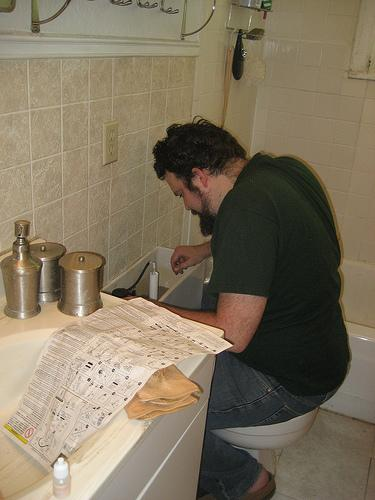What is the man in the image doing and how is he dressed? The man is fixing a toilet while wearing a black shirt, blue jeans, and tan work gloves. If you were to ask a complex question about this image, what would it be, and what would the answer entail? Answer: The man's attire, including a casual black shirt and blue jeans along with tan work gloves, suggests that he may not be a professional plumber. The presence of an instruction paper indicates that he might be attempting a DIY repair job. List three objects in the image that are related to electrical outlets or connections. Standard white electric outlet, electrical outlet in the wall, and a white power outlet. In the context of the image, what is the likely sentiment or emotion you derive from observing the man's actions? The sentiment could be interpreted as focused or determined, as the man is engrossed in repairing the toilet. Comment on the image quality, specifically in terms of details and visible information. The image quality is good, providing a clear view of details, objects, and visible information captured in the scene. Identify the main object on the sink and describe its appearance. Three stainless steel containers on the top of the sink, with a dirty metal soap dispenser and silver pump. Analyze the primary purpose of the man being in the bathroom and his intent on interacting with the objects. The primary purpose of the man's presence is to repair the white toilet, and he interacts with objects such as the instructions on the sink and toilet components. What is the most prominent color scheme of the image, particularly in the wall tiles and floor? The dominant color scheme includes clean white and beige tones in the wall tiles and floor. Narrate the atmosphere of the bathroom setting in the image. The bathroom has a clean and organized atmosphere, featuring a white-and-beige tiled wall, clean tile floor, and well-arranged silver bathroom accessories. Examine the image and provide a count of distinct bathroom items present. There are 21 distinct bathroom items in the image. What additional safety feature can be seen on the wall in the image? standard white electric outlet What is the color of the gloves present in the image? tan What type of document can be seen in the image, and what is its purpose? An extra-large instruction paper to guide the man in repairing the toilet. What is the main color of the wall tiles in the image? beige Find the purple-striped curtains on the right side of the bathroom and name the material they are made of. Please ensure that these curtains are properly closed to maintain privacy. No, it's not mentioned in the image. What is the object that can be found inside the toilet? uncovered toilet base What is the main event taking place in the image? A man is repairing a toilet. There is an object mounted on the wall holding various accessories. What is that object? bathroom shower caddy What is the color of the shirt the man is wearing? black What is the description of the plastic bottle found in the image? Plastic bottle with chemical and a white top. In the context of this image, what action is the man performing that may involve understanding a diagram? The man is following instructions on a paper to repair the toilet. Describe the appearance of the floor shown in the image. The floor has clean tiles with grout. Create a fun and humorous caption inspired by the image.  In the middle of his bathroom beauty treatment, the DIY king discovered a whole new level of multitasking - fixing the royal throne while seated on it! Find the object with the description: dirty metal soap dispenser. What is its color? Silver What is the purpose of the wall attached silver towel hanger in the image? To hang towels and other bathroom accessories. Is the man sitting or standing in the image, and what is he doing?  The man is sitting on a toilet while repairing it. Choose the correct statement about the man in the image: B. Man has a shaved head Write a detailed and compelling caption describing the scene displayed in the image.  A skillful man with brown hair and a black beard, dressed in a black t-shirt and blue jeans, meticulously repairs a white toilet, following the detailed instructions laid out on an extra-large paper nearby. The pristine bathroom, adorned with clean white and beige wall tiles, features a white sink, a white bathtub, and carefully organized stainless steel containers. How many stainless steel containers can be seen on the top of the sink? three 